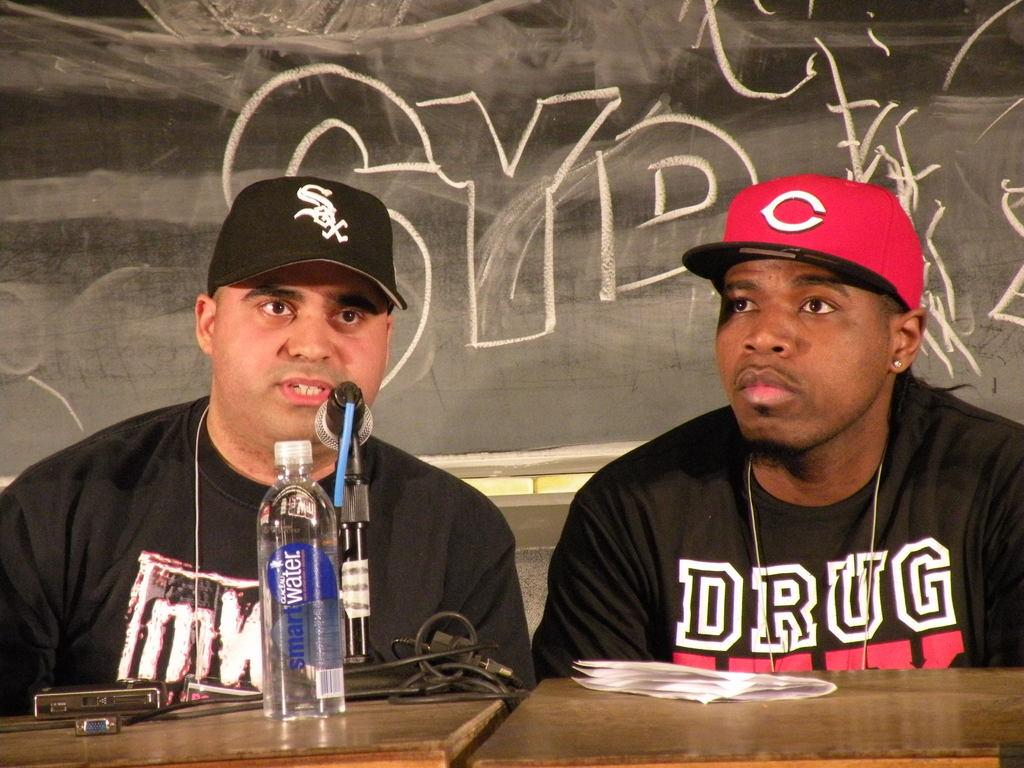<image>
Relay a brief, clear account of the picture shown. A man wearing a White Sox hat is sitting at a desk with a man wearing a red hat with a C on it. 